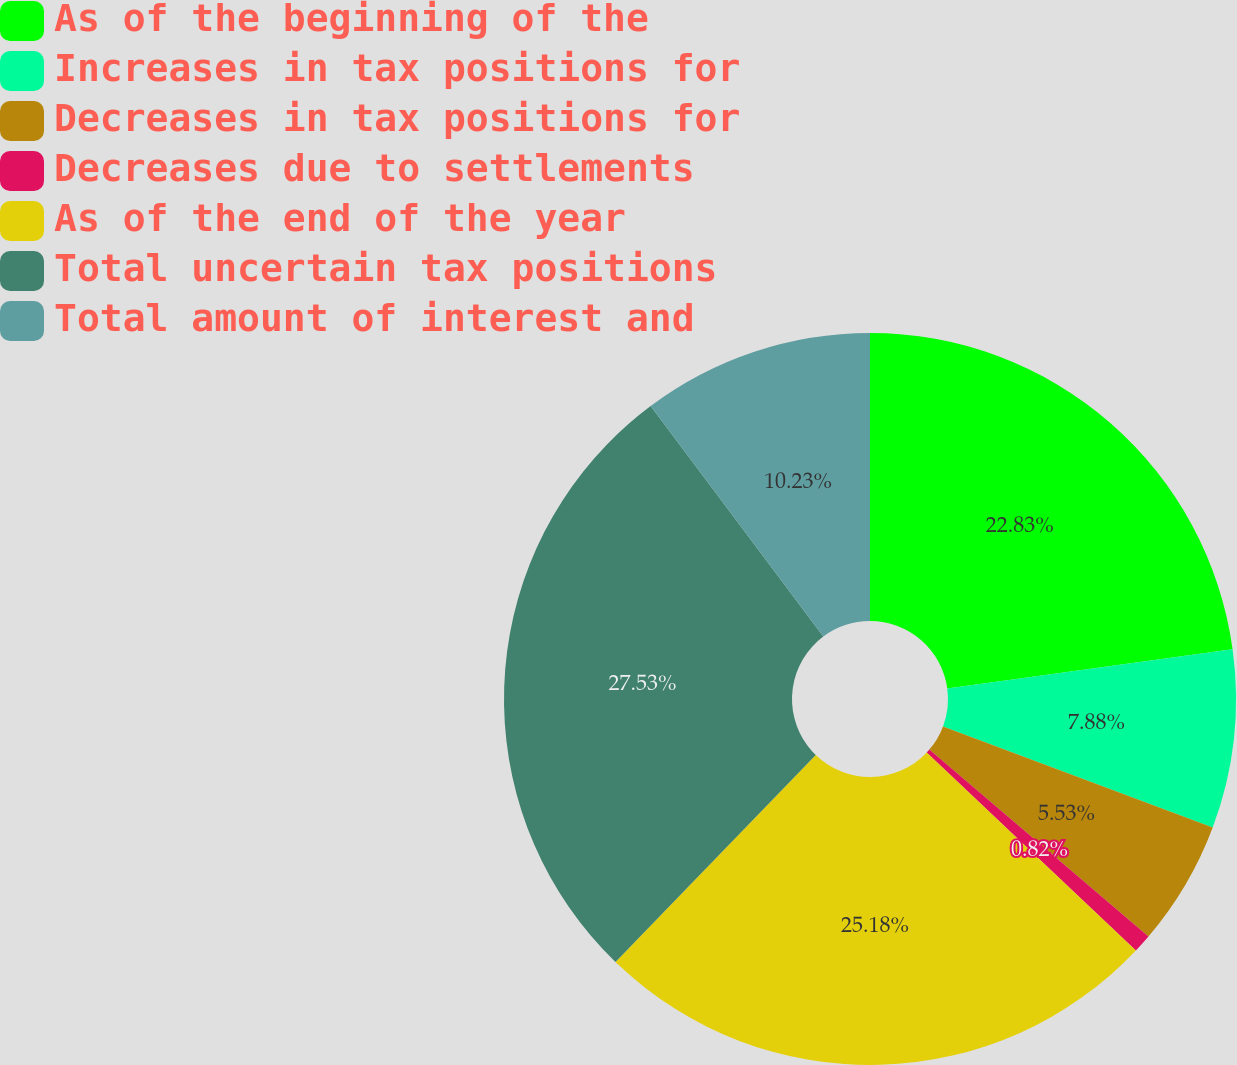Convert chart. <chart><loc_0><loc_0><loc_500><loc_500><pie_chart><fcel>As of the beginning of the<fcel>Increases in tax positions for<fcel>Decreases in tax positions for<fcel>Decreases due to settlements<fcel>As of the end of the year<fcel>Total uncertain tax positions<fcel>Total amount of interest and<nl><fcel>22.83%<fcel>7.88%<fcel>5.53%<fcel>0.82%<fcel>25.18%<fcel>27.53%<fcel>10.23%<nl></chart> 